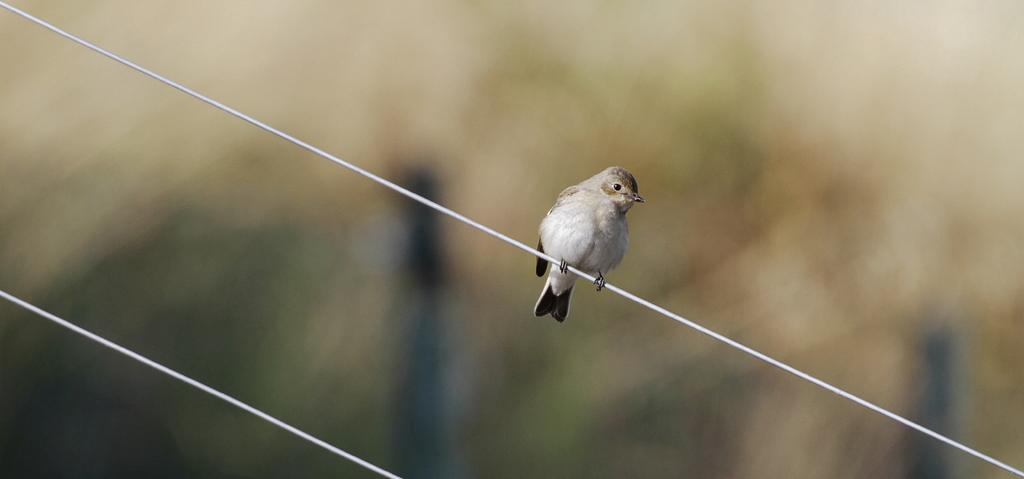What type of animal is in the image? There is a bird in the image. Where is the bird located? The bird is on a wire. Can you describe the background of the image? The background of the image is blurred. What color is the grape that the bird is holding in its beak in the image? There is no grape present in the image, and the bird is not holding anything in its beak. 